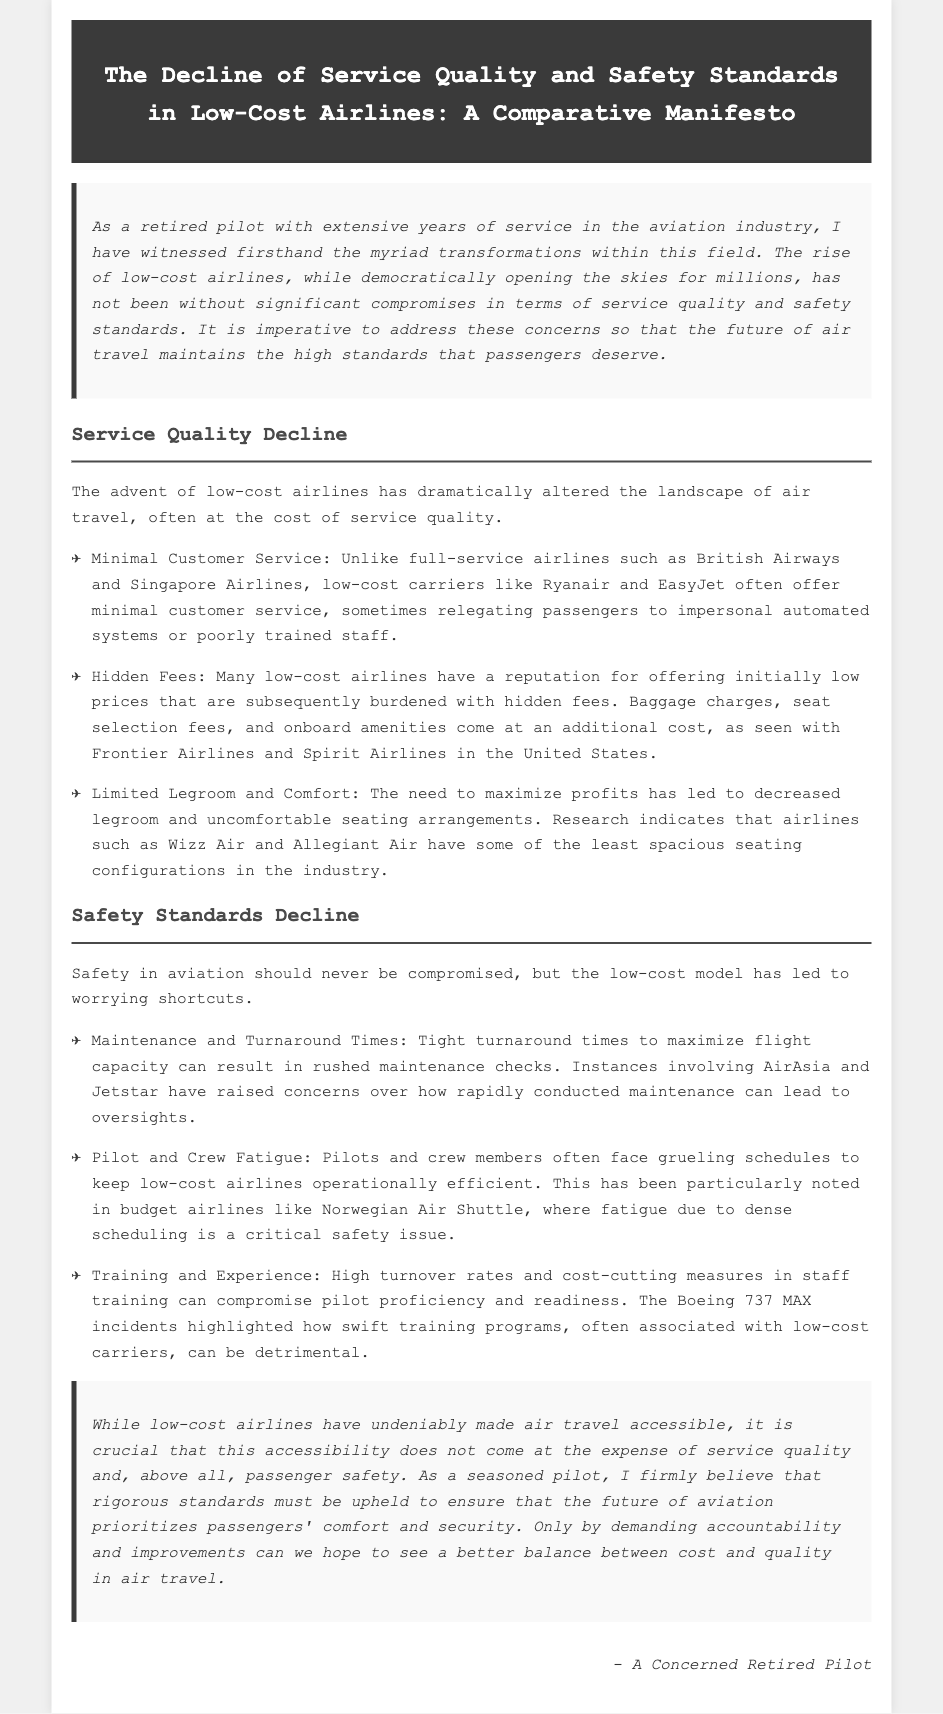What is the title of the document? The title is specified in the header section of the document.
Answer: The Decline of Service Quality and Safety Standards in Low-Cost Airlines: A Comparative Manifesto Who authored the document? The author's perspective is introduced in the introduction section.
Answer: A Concerned Retired Pilot What airlines are compared to low-cost carriers regarding customer service? The document mentions specific full-service airlines to contrast service quality with low-cost airlines.
Answer: British Airways and Singapore Airlines Which low-cost airline is mentioned for hidden fees? The document provides examples of low-cost airlines that practice charging hidden fees.
Answer: Frontier Airlines What issue does pilot fatigue relate to? The document discusses pilot fatigue in the context of operational efficiency.
Answer: Safety Which two low-cost airlines are cited for maintenance concerns? The document lists certain airlines in relation to maintenance checks and safety standards.
Answer: AirAsia and Jetstar What is a consequence of tight turnaround times? The document explains that tight turnaround times can impact operational practices.
Answer: Rushed maintenance checks What type of standards does the author believe should be upheld? The conclusion emphasizes the importance of maintaining specific standards in aviation.
Answer: Rigorous standards 